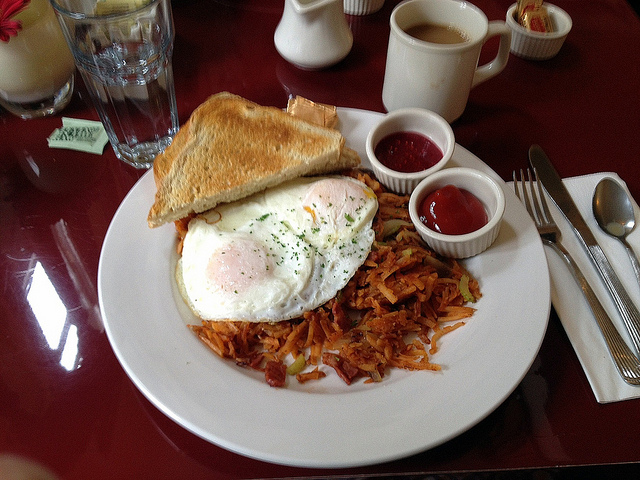How do the various food items on the plate complement each other to make a balanced breakfast? The presented breakfast on the plate is meticulously balanced for a fulfilling morning meal. The crispy, savory hash browns offer a delightful contrast with the soft, tender poached eggs, while the crunchy toasted bread serves as a great carrier for either butter or ketchup. The ketchup adds a zesty sweetness that enhances the overall flavors. Together, these elements provide a pleasant mix of textures and tastes, covering the essentials of a nutritious breakfast by including proteins, carbohydrates, and a bit of vegetables from the potato. 